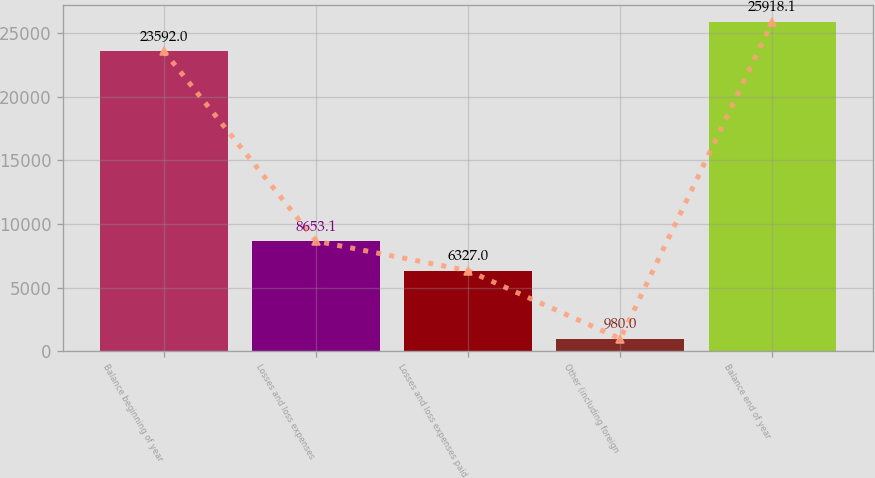Convert chart. <chart><loc_0><loc_0><loc_500><loc_500><bar_chart><fcel>Balance beginning of year<fcel>Losses and loss expenses<fcel>Losses and loss expenses paid<fcel>Other (including foreign<fcel>Balance end of year<nl><fcel>23592<fcel>8653.1<fcel>6327<fcel>980<fcel>25918.1<nl></chart> 